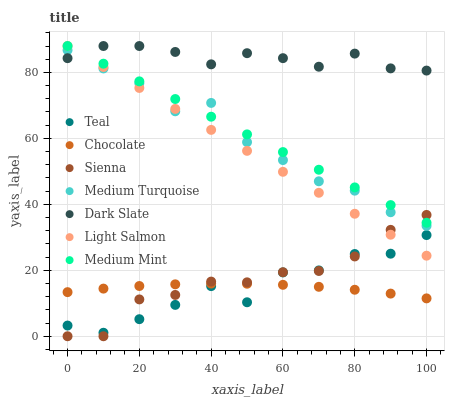Does Chocolate have the minimum area under the curve?
Answer yes or no. Yes. Does Dark Slate have the maximum area under the curve?
Answer yes or no. Yes. Does Light Salmon have the minimum area under the curve?
Answer yes or no. No. Does Light Salmon have the maximum area under the curve?
Answer yes or no. No. Is Light Salmon the smoothest?
Answer yes or no. Yes. Is Teal the roughest?
Answer yes or no. Yes. Is Teal the smoothest?
Answer yes or no. No. Is Light Salmon the roughest?
Answer yes or no. No. Does Sienna have the lowest value?
Answer yes or no. Yes. Does Light Salmon have the lowest value?
Answer yes or no. No. Does Dark Slate have the highest value?
Answer yes or no. Yes. Does Teal have the highest value?
Answer yes or no. No. Is Chocolate less than Light Salmon?
Answer yes or no. Yes. Is Dark Slate greater than Sienna?
Answer yes or no. Yes. Does Light Salmon intersect Sienna?
Answer yes or no. Yes. Is Light Salmon less than Sienna?
Answer yes or no. No. Is Light Salmon greater than Sienna?
Answer yes or no. No. Does Chocolate intersect Light Salmon?
Answer yes or no. No. 